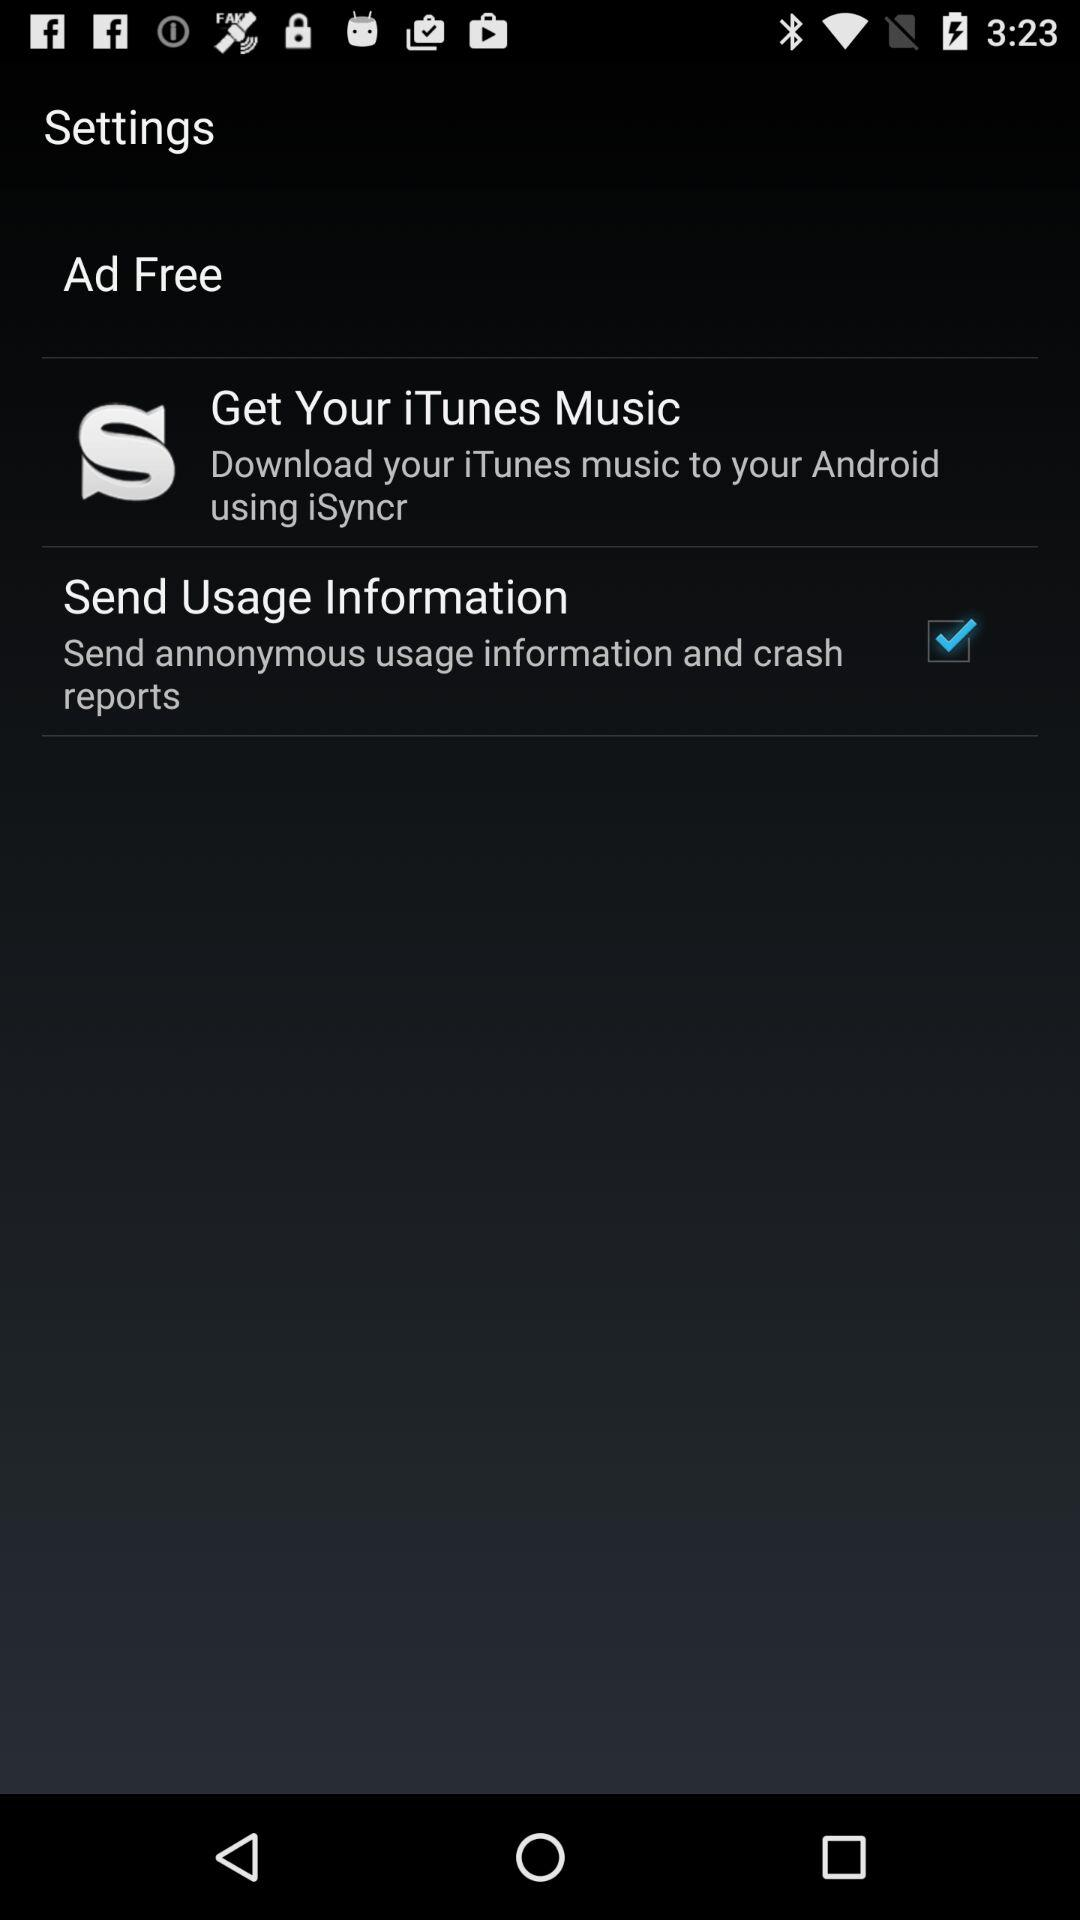Which option is marked as checked? The checked option is "Send Usage Information". 